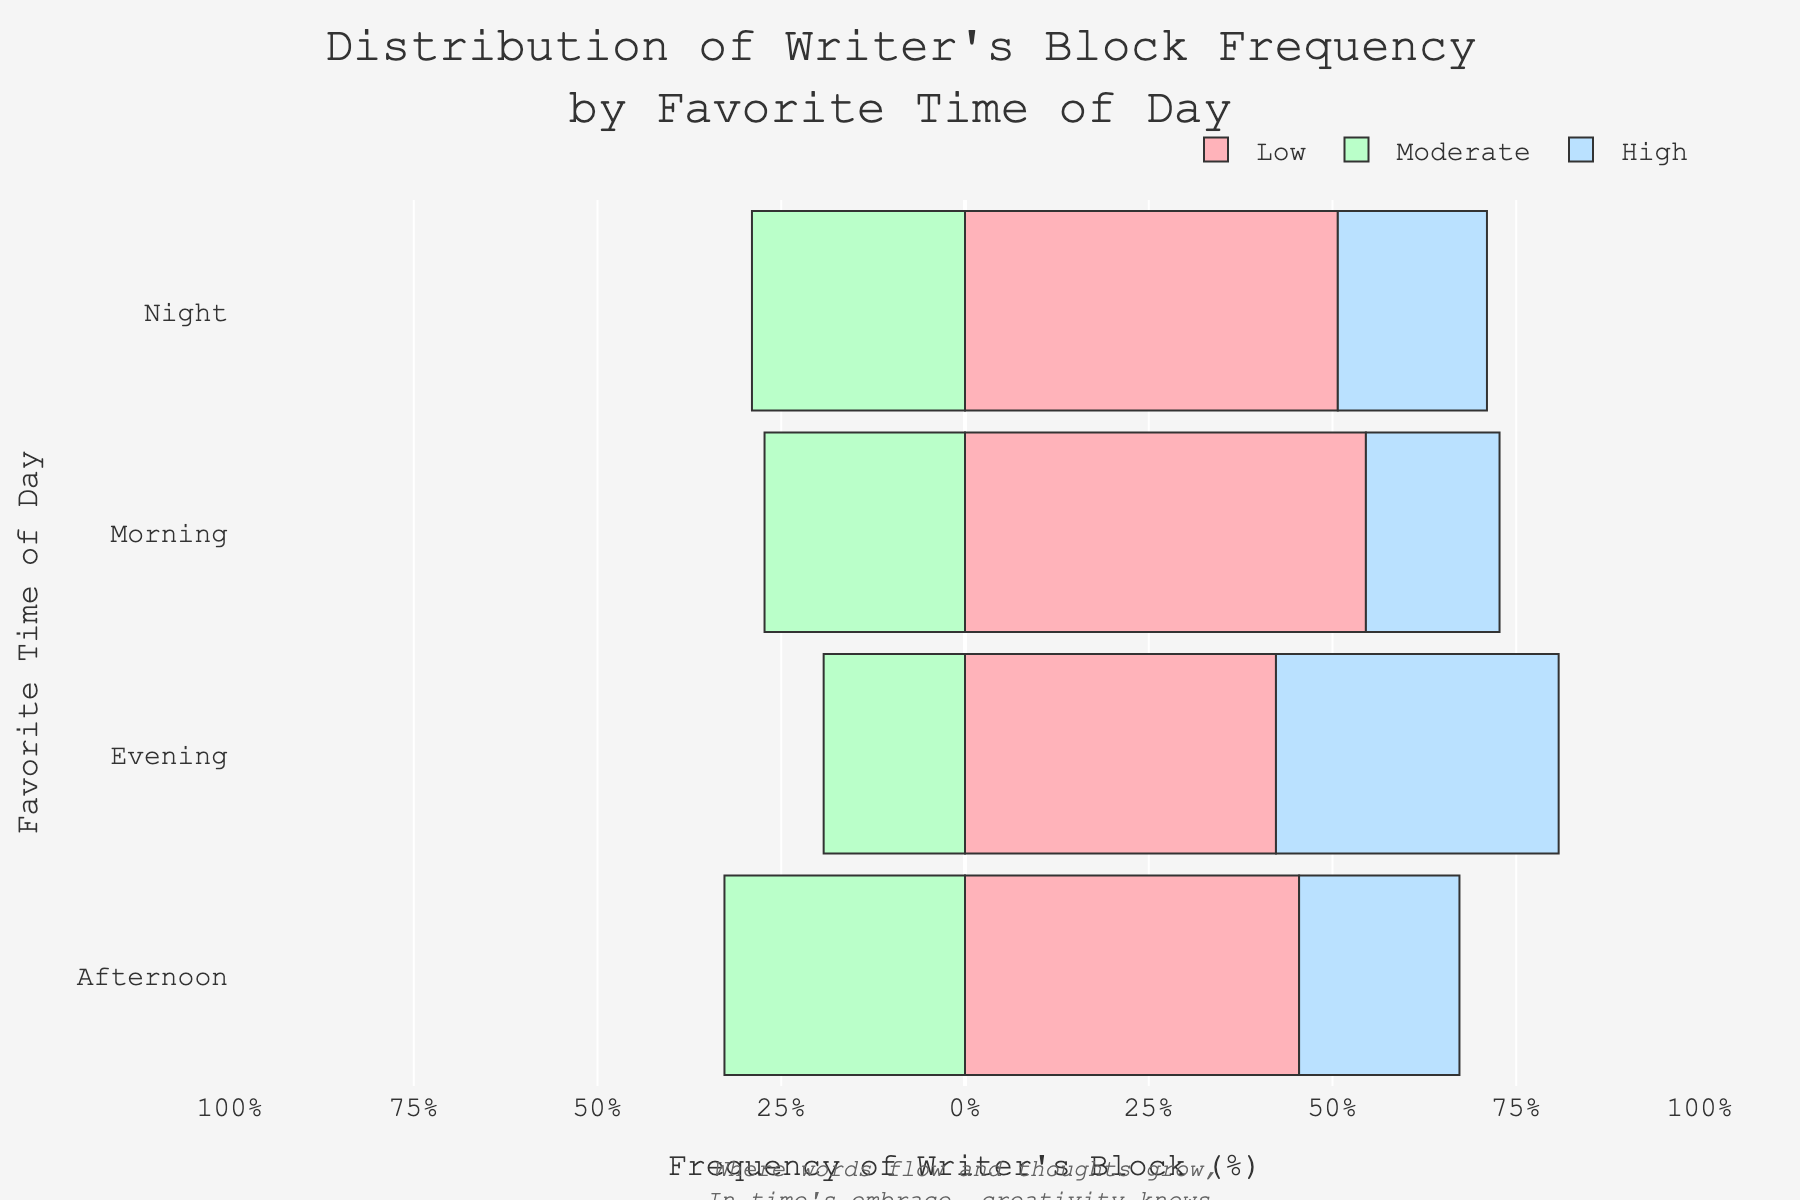What percentage of writer's block incidents are classified as high during the morning? In the figure, for the morning time of day, the "High" category is shown as a percentage of total incidents. The exact percentage value is displayed directly on the bar in the chart.
Answer: 20% Which time of day has the highest percentage of low-frequency writer's block incidents? By observing the chart, identify the bar segment representing "Low" frequency with the highest percentage value among all time-of-day categories.
Answer: Night How does the percentage of moderate writer's block incidents in the afternoon compare to that in the evening? In the chart, check the moderate category bars for afternoon and evening. Compare their negative values as the "Moderate" category bars extend to the left side.
Answer: Afternoon is higher than evening What is the combined percentage of low and moderate writer's block incidents for writers who prefer the evening? Sum the percentages of the "Low" and "Moderate" categories for the evening from the chart. From visual information, add the two values together.
Answer: 48% Between morning and night writers, who experiences a higher percentage of high-frequency writer's block? Compare the percentage values of the "High" category for morning and night from the chart bars. Identify which has a higher value.
Answer: Night What is the overall visual trend of writer's block frequency in the morning versus night? Look at the overall bar patterns for morning and night. Determine how the frequencies (low, moderate, high) are distributed for each time of day through the visual elements.
Answer: Morning has higher low-frequency and night has higher high-frequency Is the percentage of low-frequency writer's block in the evening greater than in the afternoon? Directly compare the percentage value of the "Low" category between evening and afternoon in the chart bars.
Answer: No Which time of day shows the most balanced distribution across low, moderate, and high writer's block incidents? Examine each time of day's bar segments to see which one has the most uniform distribution without any extreme tall or short segments.
Answer: Morning 